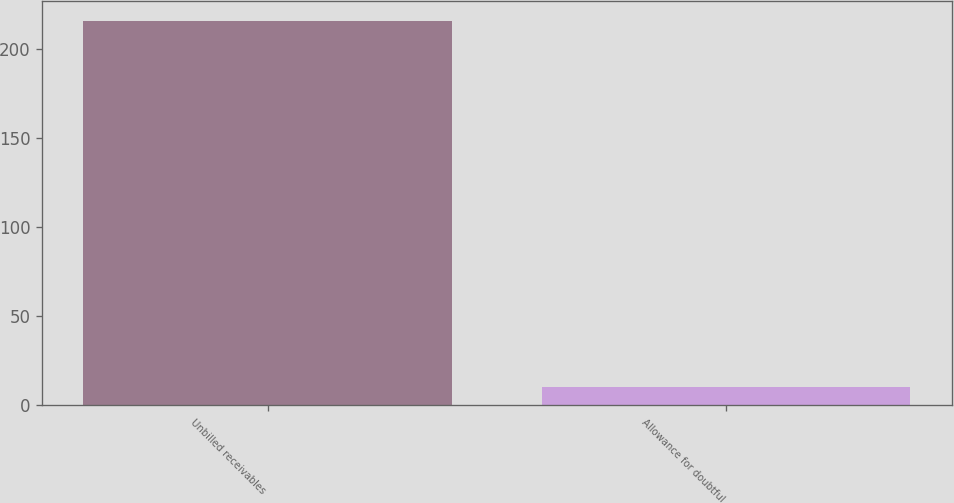<chart> <loc_0><loc_0><loc_500><loc_500><bar_chart><fcel>Unbilled receivables<fcel>Allowance for doubtful<nl><fcel>216<fcel>10<nl></chart> 